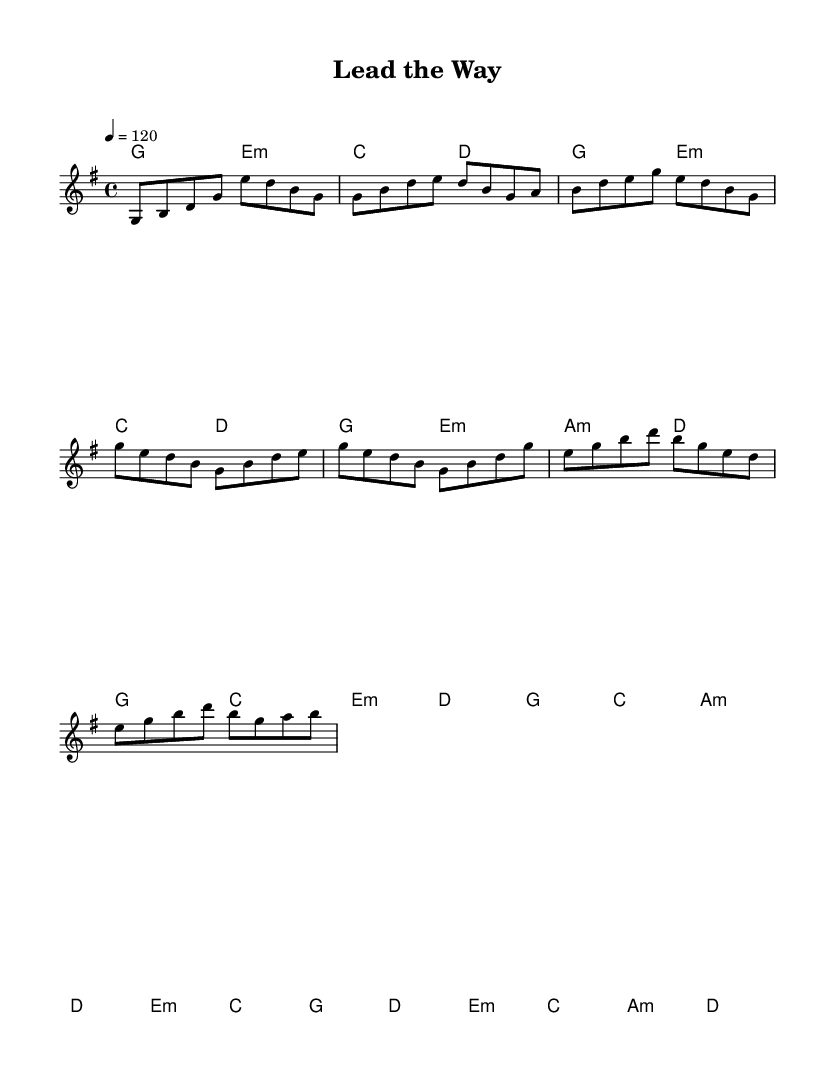What is the key signature of this music? The key signature is G major, which has one sharp (F#) indicated by the key signature at the beginning of the staff.
Answer: G major What is the time signature of this piece? The time signature is 4/4, indicating that there are four beats in each measure and a quarter note gets one beat. This is shown near the beginning of the notation.
Answer: 4/4 What is the tempo marking for this piece? The tempo marking is 120, which indicates that the piece should be played at 120 beats per minute. This is found in the tempo indication at the beginning of the score.
Answer: 120 How many measures are in the chorus section? The chorus consists of 4 measures, which can be counted visually in the score by identifying the measures that correspond to the chorus section.
Answer: 4 Which chord appears at the beginning of the bridge? The bridge starts with an E minor chord, which is indicated by the chord symbols above the staff at the beginning of the bridge section.
Answer: E minor What is the characteristic rhythmic feel commonly found in R&B songs present in this piece? The piece employs a syncopated rhythm, which is a common feature in Rhythm and Blues, providing a groovy feel that emphasizes off-beats and creates a lively atmosphere.
Answer: Syncopation What is the primary emotion conveyed through the lyrics suggested by the melody? The primary emotion is empowerment, as the energetic nature of the melody and rhythm suggests themes of motivation and leadership, typical of anthems meant to inspire teams.
Answer: Empowerment 